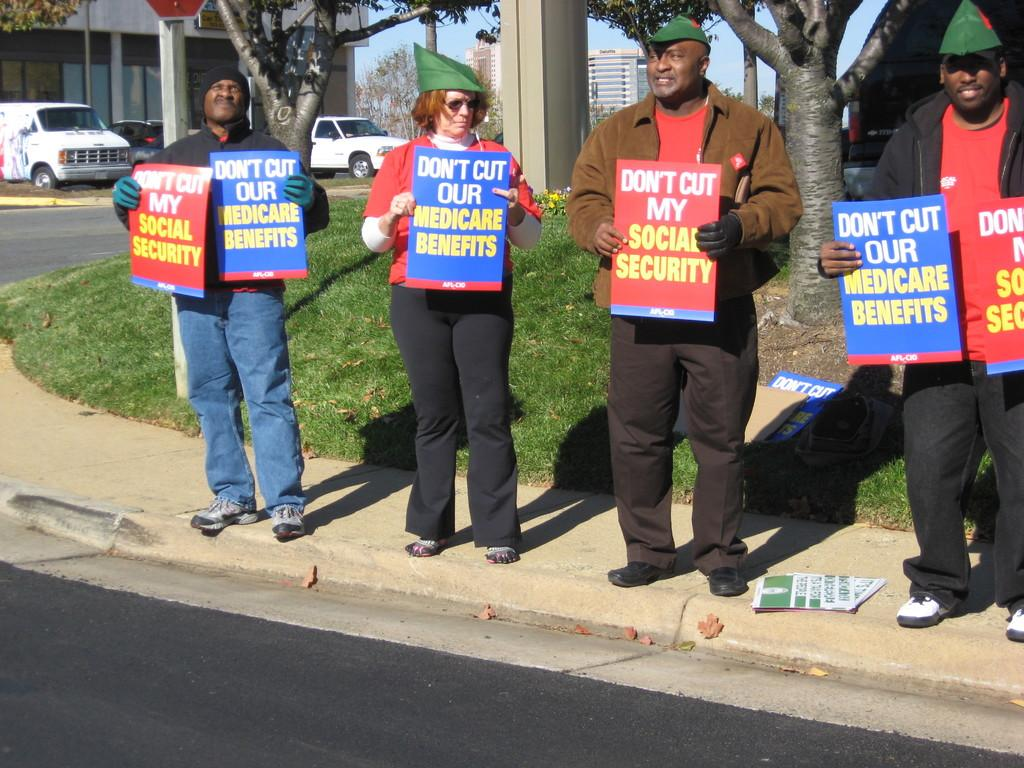How many people are in the image? There are four persons in the image. What are the persons holding in the image? The persons are holding placards in the image. Where are the persons standing in the image? The persons are standing beside a road in the image. What can be seen on the road in the image? There is text on the road in the image. What is visible in the background of the image? Trees, a pillar, a building, and the sky are visible in the background of the image. What else can be seen in the background of the image? Vehicles are visible in the background of the image. What type of glass is being used to fix the wrench in the image? There is no glass or wrench present in the image. 